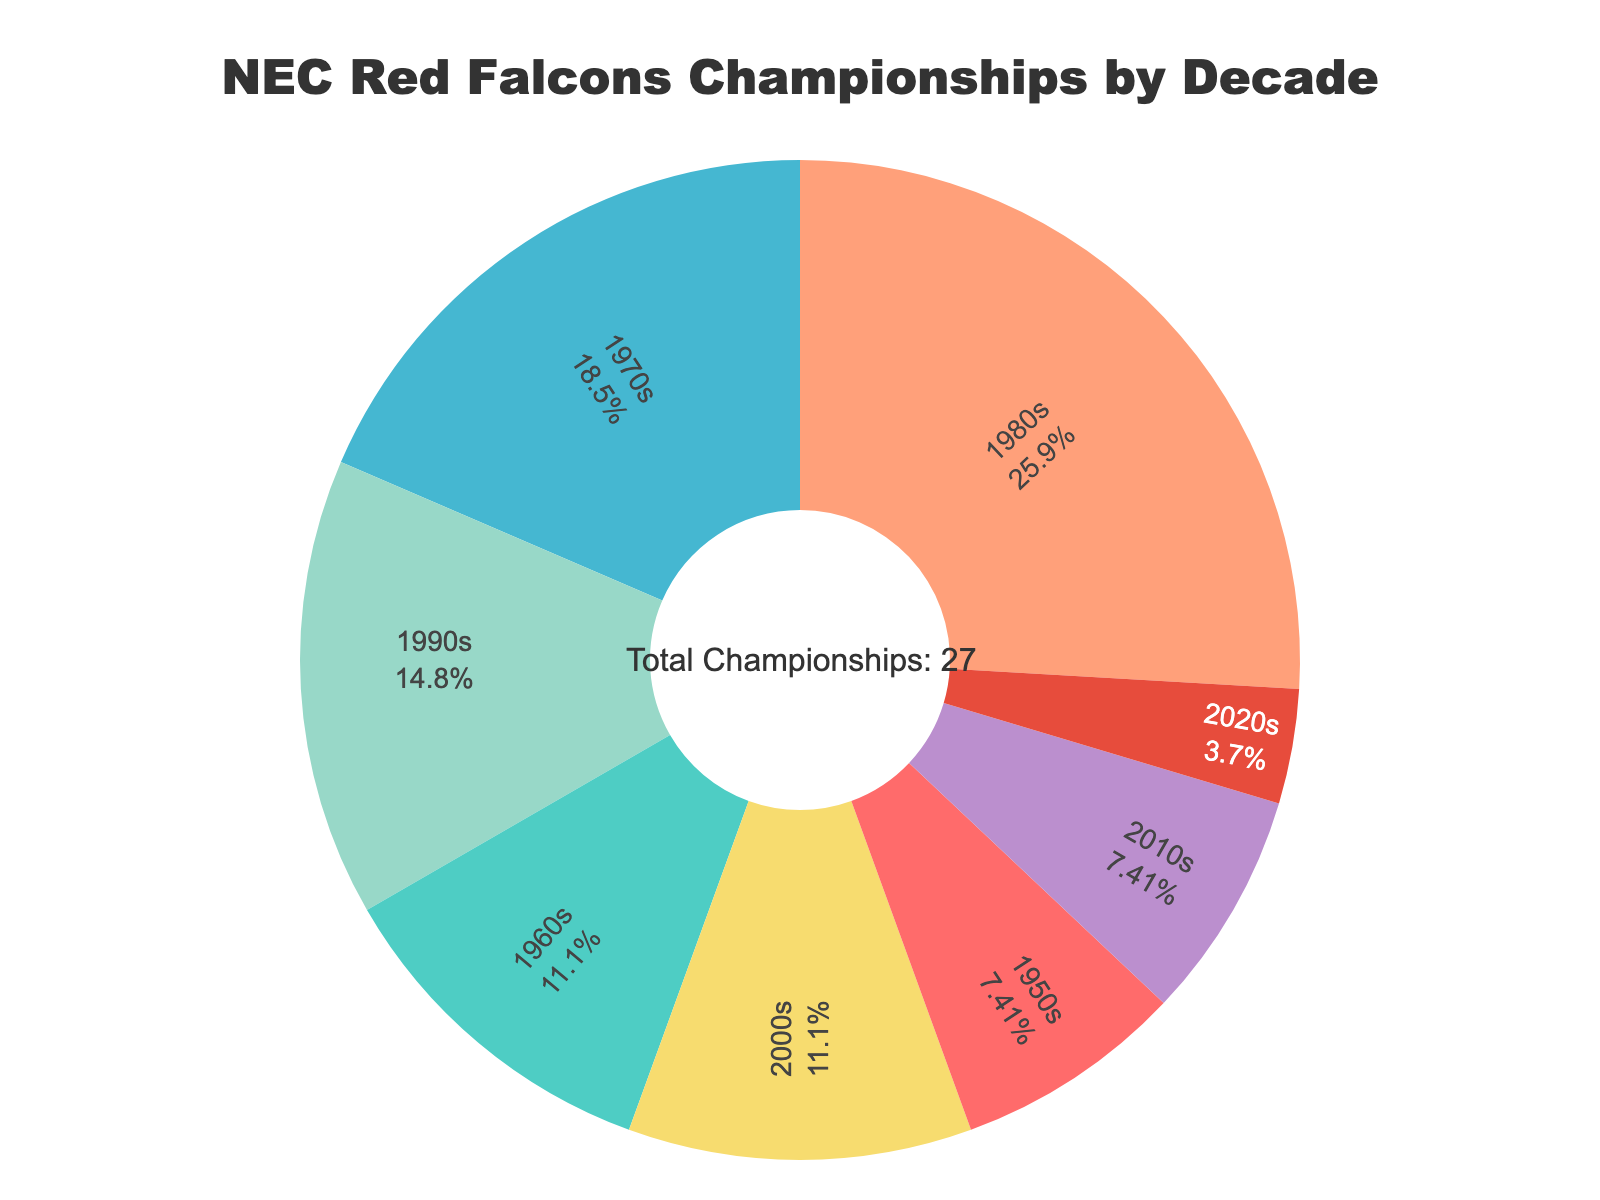What decade saw the highest number of championships for NEC Red Falcons? By looking at the pie chart, observe the segment with the largest size. The 1980s segment occupies the largest portion of the chart, indicating the highest number of championships.
Answer: 1980s Which two decades combined account for more championships than any other combination? First, identify the two decades with the highest championships: the 1980s (7) and the 1970s (5). Summing these, we get 7 + 5 = 12. Checking other combinations, none exceed 12.
Answer: 1980s and 1970s What percentage of total championships were won in the 1990s? Identify the 1990s segment, which shows 4 championships. Total championships sum up to 27 (2 + 3 + 5 + 7 + 4 + 3 + 2 + 1). Calculate the percentage: (4/27)*100 ≈ 14.81%
Answer: 14.81% How does the number of championships in the 2020s compare to the 1950s? The pie chart shows 1 championship in the 2020s and 2 in the 1950s. Comparing these, the 1950s had twice as many as the 2020s.
Answer: 1950s had more Which decade is represented by the green segment, and how many championships does it account for? Locate the green segment visually; it corresponds to the 1960s. The chart indicates the 1960s account for 3 championships.
Answer: 1960s with 3 championships What is the total number of championships won from 2000 onwards? Sum championships from the 2000s (3), 2010s (2), and 2020s (1). Adding these together: 3 + 2 + 1 = 6.
Answer: 6 If the 1980s championships were reduced by half, which decade would then have the highest number of championships? Halving the 1980s championships (7 / 2 = 3.5). Compare other decades: 1970s have 5, which would be higher than 3.5. Therefore, the 1970s would then have the most.
Answer: 1970s What is the difference in championships between the decades with the most and least championships? Identify the decade with the most (1980s, 7) and the least (2020s, 1). Subtract the smallest from the largest: 7 - 1 = 6.
Answer: 6 By combining the championships of the 1970s and 2010s, do they surpass the total of the 1990s? The 1970s have 5 championships and the 2010s have 2, summing to 5 + 2 = 7. The 1990s alone have 4 championships, so 7 is greater than 4.
Answer: Yes Which two decades together represent exactly half of all championships? Total championships are 27. Half is 27 / 2 = 13.5. Combining the 1980s (7) and 1990s (4) with the 2010s (2) gives 7 + 4 + 2 = 13, which is closest to 13.5.
Answer: 1980s and 1990s 